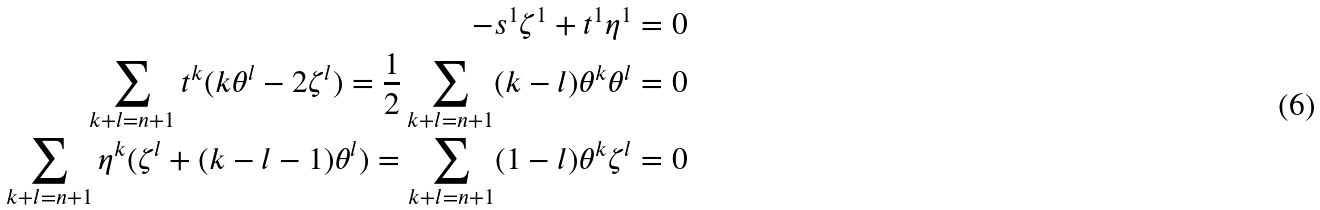Convert formula to latex. <formula><loc_0><loc_0><loc_500><loc_500>- s ^ { 1 } \zeta ^ { 1 } + t ^ { 1 } \eta ^ { 1 } = 0 \\ \sum _ { k + l = n + 1 } t ^ { k } ( k \theta ^ { l } - 2 \zeta ^ { l } ) = \frac { 1 } { 2 } \sum _ { k + l = n + 1 } ( k - l ) \theta ^ { k } \theta ^ { l } = 0 \\ \sum _ { k + l = n + 1 } \eta ^ { k } ( \zeta ^ { l } + ( k - l - 1 ) \theta ^ { l } ) = \sum _ { k + l = n + 1 } ( 1 - l ) \theta ^ { k } \zeta ^ { l } = 0</formula> 